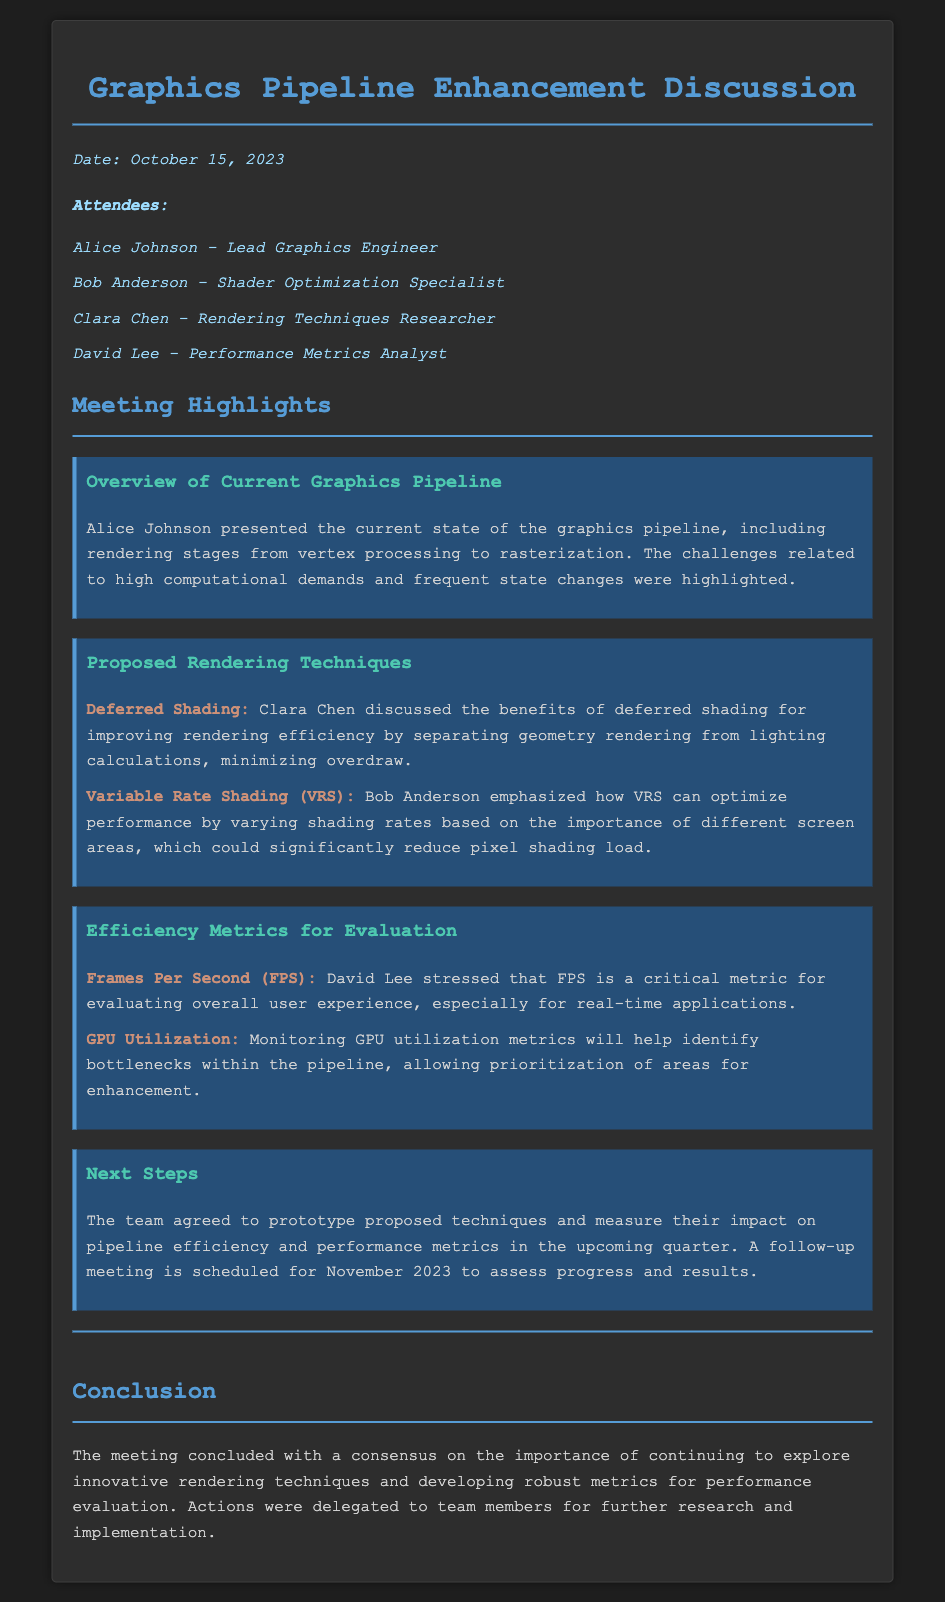What date was the meeting held? The date of the meeting is explicitly mentioned as October 15, 2023.
Answer: October 15, 2023 Who presented the current state of the graphics pipeline? The document states that Alice Johnson presented the current state of the graphics pipeline.
Answer: Alice Johnson What rendering technique emphasizes varying shading rates? Bob Anderson discussed Variable Rate Shading, which emphasizes varying shading rates based on screen areas.
Answer: Variable Rate Shading Which metric is critical for evaluating user experience? The document mentions that Frames Per Second (FPS) is a critical metric for evaluating user experience.
Answer: Frames Per Second (FPS) What is the next step agreed upon by the team? The team agreed to prototype proposed techniques and measure their impact on pipeline efficiency.
Answer: Prototype proposed techniques How many attendees were present at the meeting? When counting the listed names, there are four attendees mentioned in the minutes.
Answer: Four 